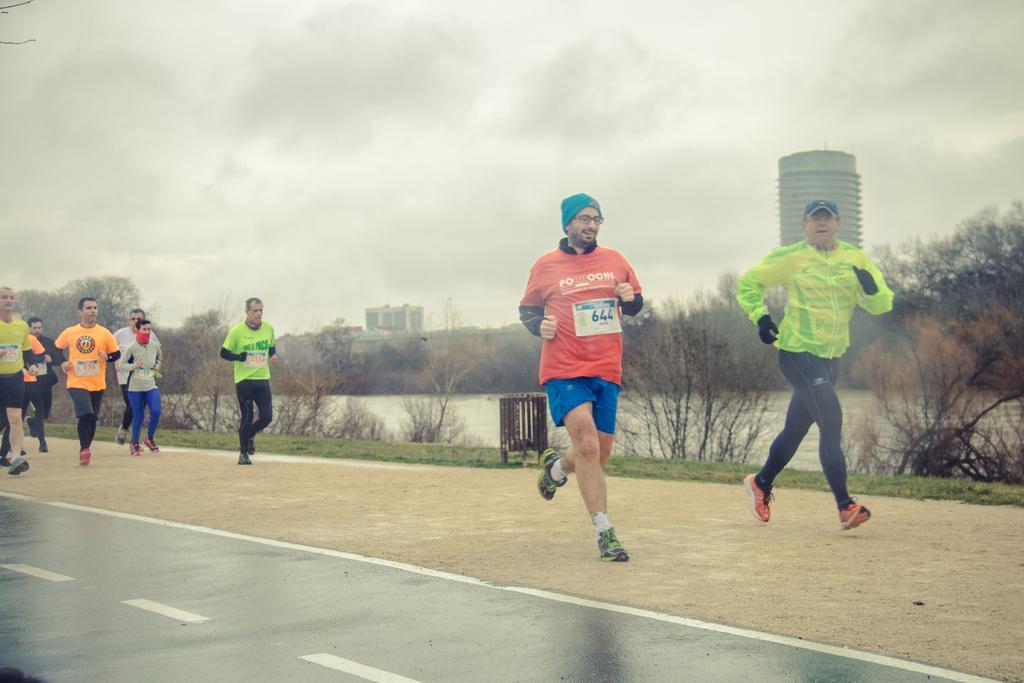How would you summarize this image in a sentence or two? In this image, we can see there are persons in different color dresses, running on the ground. Beside this ground, there is a road, on which there are white color lines. In the background, there are trees, water, buildings and grass on the ground and there are clouds in the sky. 